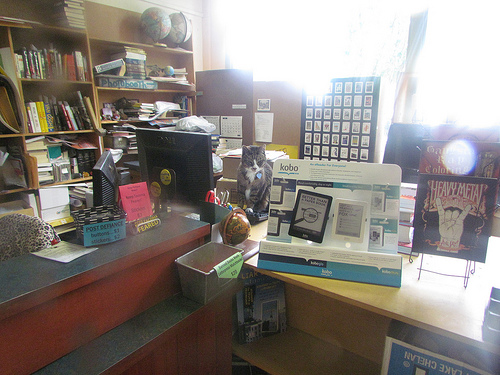<image>
Can you confirm if the shelf is behind the table? Yes. From this viewpoint, the shelf is positioned behind the table, with the table partially or fully occluding the shelf. 